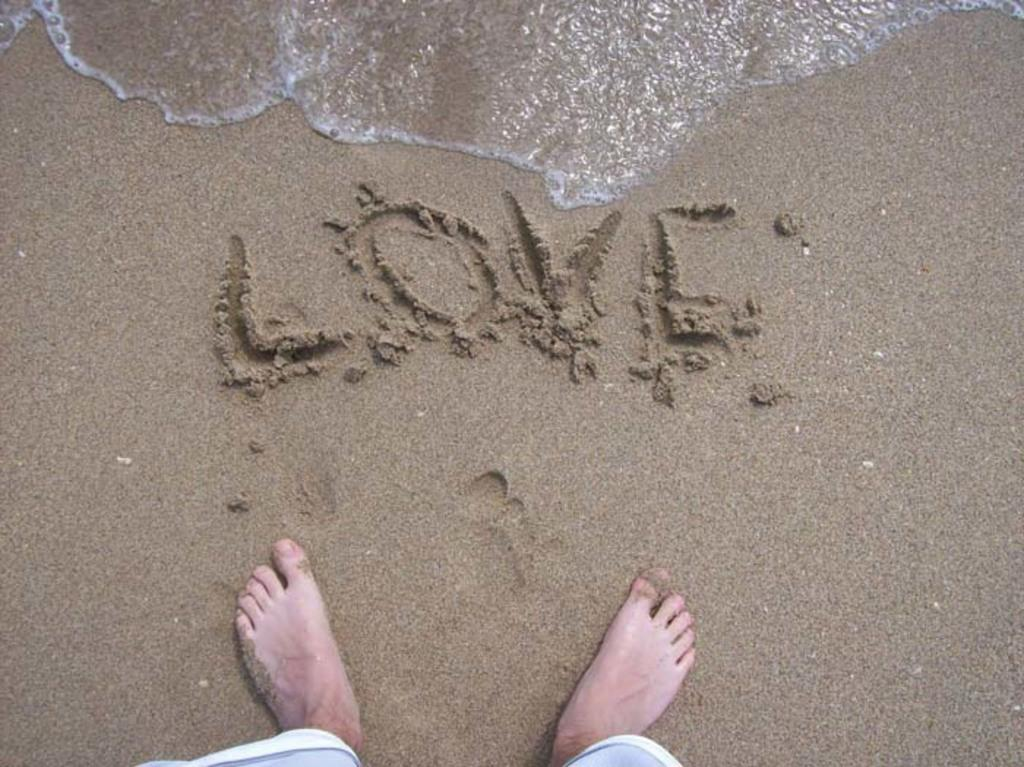What type of surface is visible in the image? There is sand in the image. What is written on the sand? The word "LOVE" is written on the sand. What else can be seen in the image besides the sand? There is water visible in the image. Can you describe any human presence in the image? There are legs of a person in the image. What type of wool is being used to create the apparel in the image? There is no apparel or wool present in the image; it features sand with the word "LOVE" written on it and water visible in the background. 